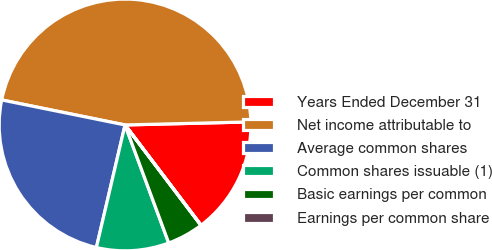<chart> <loc_0><loc_0><loc_500><loc_500><pie_chart><fcel>Years Ended December 31<fcel>Net income attributable to<fcel>Average common shares<fcel>Common shares issuable (1)<fcel>Basic earnings per common<fcel>Earnings per common share<nl><fcel>15.06%<fcel>46.43%<fcel>24.53%<fcel>9.3%<fcel>4.66%<fcel>0.02%<nl></chart> 